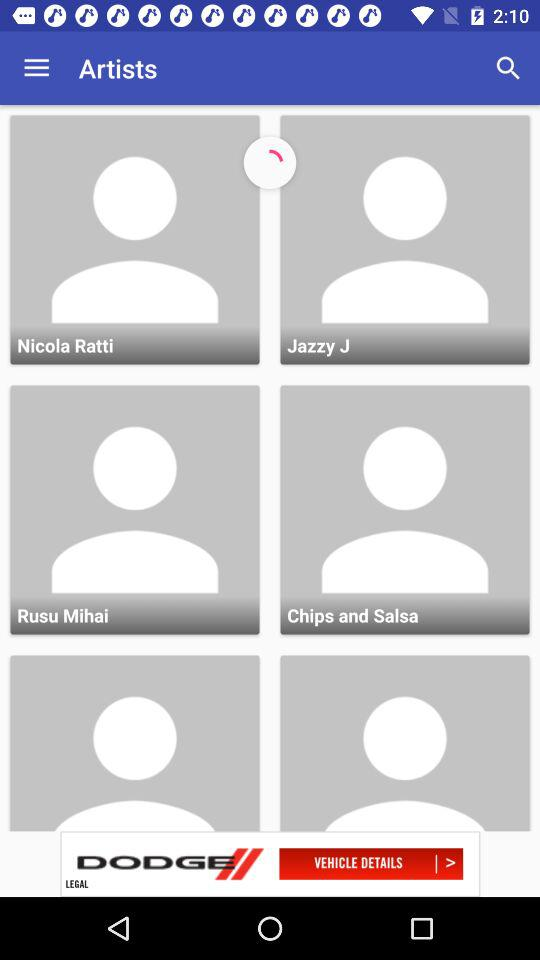What are the names of artists? The names of the artists are Nicola Ratti, Jazzy J, Rusu Milhai and "Chips and Salsa". 